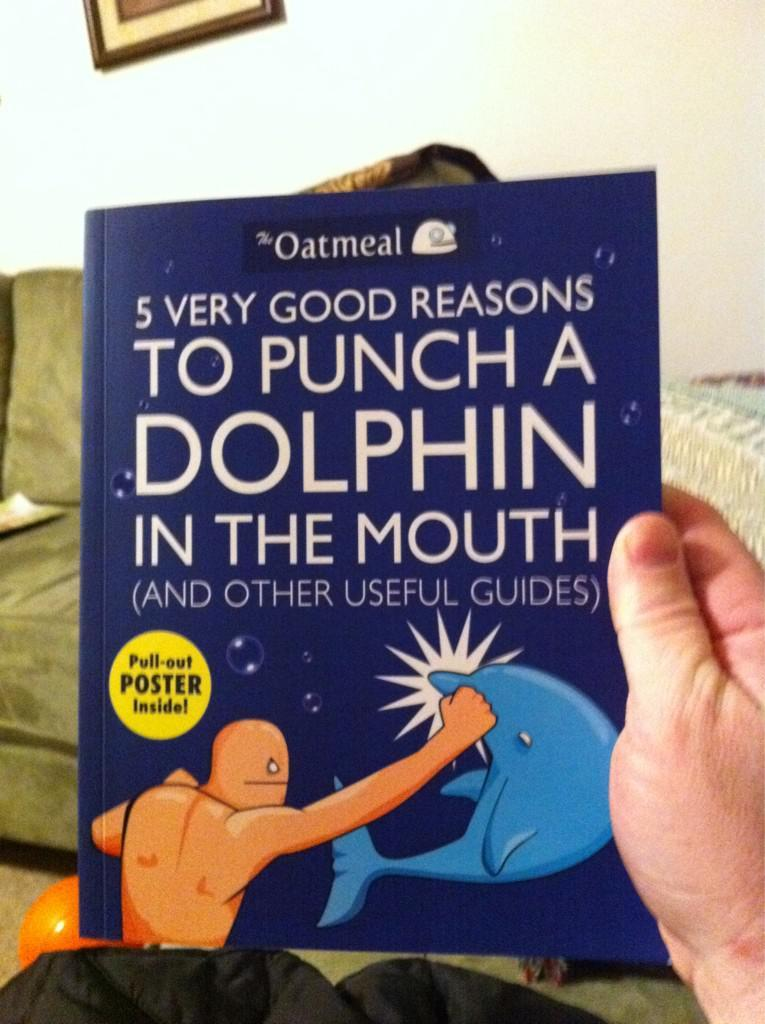<image>
Render a clear and concise summary of the photo. A book by Oatmeal called 5 very Good Reasons to Punch a Dolphin the Mouth sits on front of a soda 